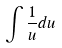<formula> <loc_0><loc_0><loc_500><loc_500>\int \frac { 1 } { u } d u</formula> 